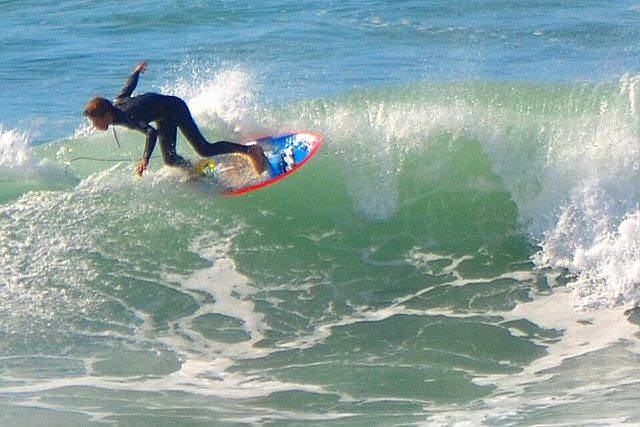Describe the objects in this image and their specific colors. I can see people in gray, black, navy, and darkgray tones and surfboard in gray, darkgray, and white tones in this image. 